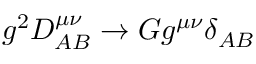Convert formula to latex. <formula><loc_0><loc_0><loc_500><loc_500>g ^ { 2 } D _ { A B } ^ { \mu \nu } \rightarrow G g ^ { \mu \nu } \delta _ { A B }</formula> 